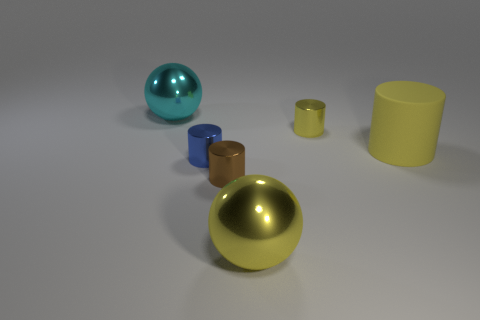Subtract all big matte cylinders. How many cylinders are left? 3 Add 1 matte cylinders. How many objects exist? 7 Subtract all yellow spheres. How many spheres are left? 1 Subtract all balls. How many objects are left? 4 Subtract 3 cylinders. How many cylinders are left? 1 Add 3 yellow cylinders. How many yellow cylinders are left? 5 Add 2 brown shiny things. How many brown shiny things exist? 3 Subtract 1 cyan balls. How many objects are left? 5 Subtract all red cylinders. Subtract all cyan spheres. How many cylinders are left? 4 Subtract all blue balls. How many yellow cylinders are left? 2 